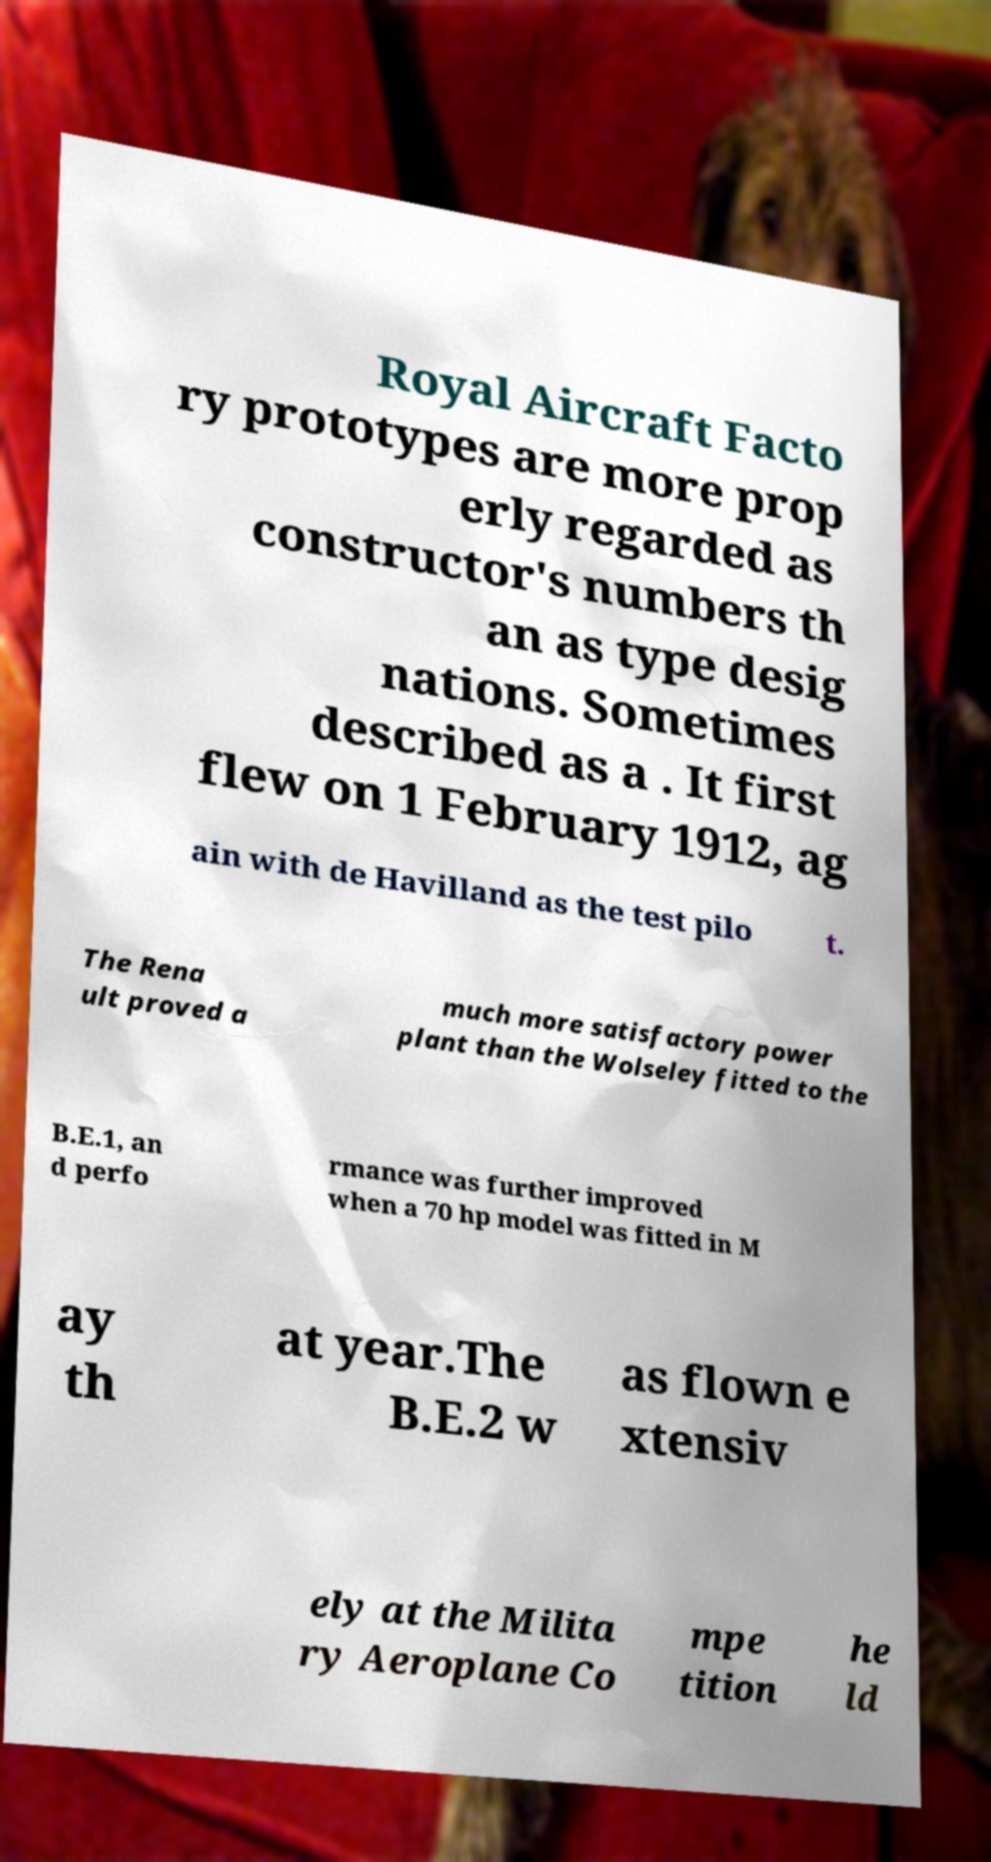Can you accurately transcribe the text from the provided image for me? Royal Aircraft Facto ry prototypes are more prop erly regarded as constructor's numbers th an as type desig nations. Sometimes described as a . It first flew on 1 February 1912, ag ain with de Havilland as the test pilo t. The Rena ult proved a much more satisfactory power plant than the Wolseley fitted to the B.E.1, an d perfo rmance was further improved when a 70 hp model was fitted in M ay th at year.The B.E.2 w as flown e xtensiv ely at the Milita ry Aeroplane Co mpe tition he ld 